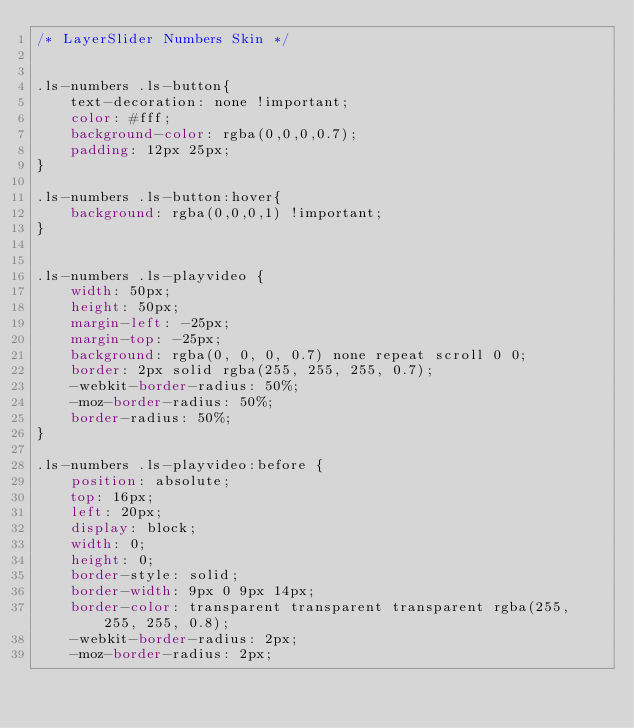<code> <loc_0><loc_0><loc_500><loc_500><_CSS_>/* LayerSlider Numbers Skin */


.ls-numbers .ls-button{
	text-decoration: none !important;
	color: #fff;
	background-color: rgba(0,0,0,0.7);
	padding: 12px 25px;
}

.ls-numbers .ls-button:hover{
	background: rgba(0,0,0,1) !important;
}


.ls-numbers .ls-playvideo {
	width: 50px;
	height: 50px;
	margin-left: -25px;
	margin-top: -25px;
	background: rgba(0, 0, 0, 0.7) none repeat scroll 0 0;
	border: 2px solid rgba(255, 255, 255, 0.7);
	-webkit-border-radius: 50%;
	-moz-border-radius: 50%;
	border-radius: 50%;
}

.ls-numbers .ls-playvideo:before {
	position: absolute;
	top: 16px;
	left: 20px;
	display: block;
	width: 0;
	height: 0;
	border-style: solid;
	border-width: 9px 0 9px 14px;
	border-color: transparent transparent transparent rgba(255, 255, 255, 0.8);
	-webkit-border-radius: 2px;
	-moz-border-radius: 2px;</code> 